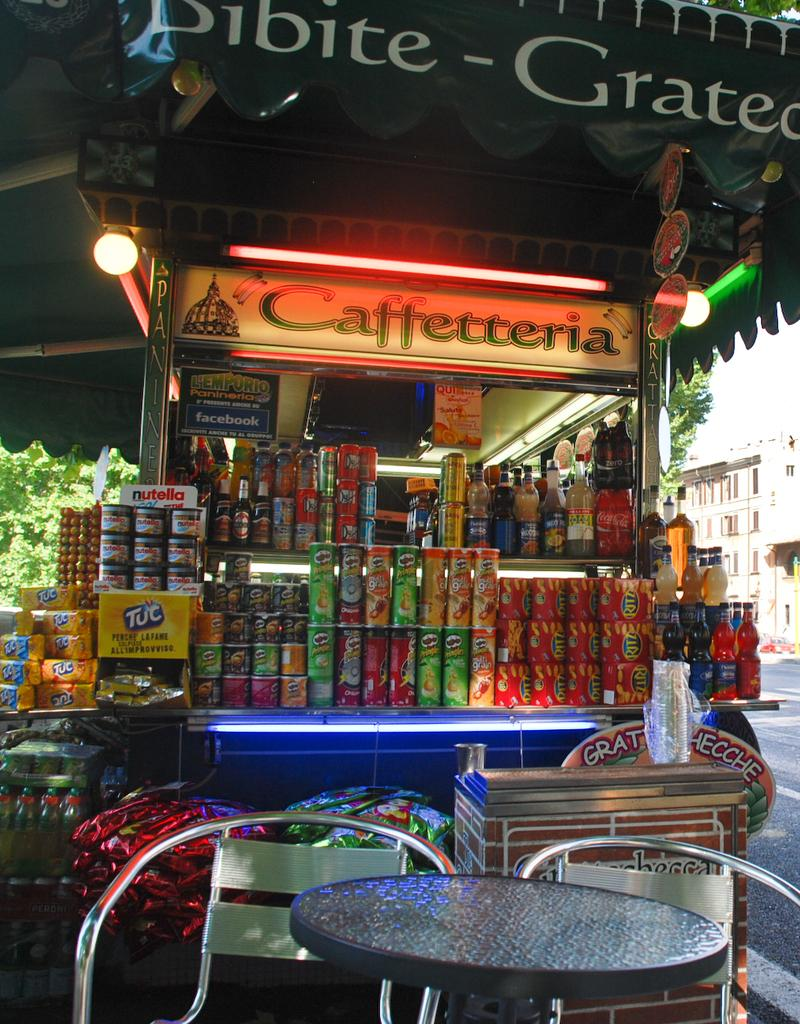<image>
Relay a brief, clear account of the picture shown. Sundries are stacked on a Caffetteria stand under an awning by the side of a street. 